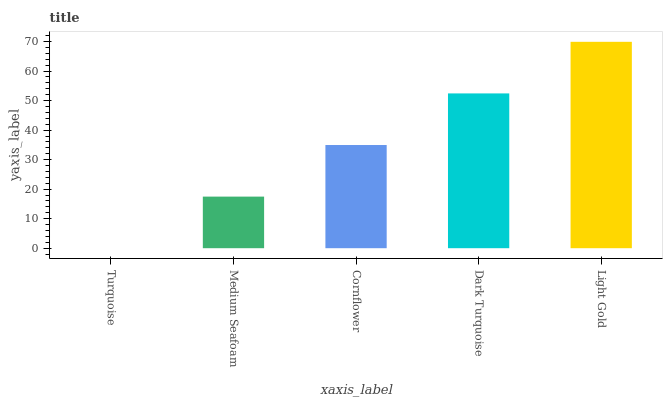Is Turquoise the minimum?
Answer yes or no. Yes. Is Light Gold the maximum?
Answer yes or no. Yes. Is Medium Seafoam the minimum?
Answer yes or no. No. Is Medium Seafoam the maximum?
Answer yes or no. No. Is Medium Seafoam greater than Turquoise?
Answer yes or no. Yes. Is Turquoise less than Medium Seafoam?
Answer yes or no. Yes. Is Turquoise greater than Medium Seafoam?
Answer yes or no. No. Is Medium Seafoam less than Turquoise?
Answer yes or no. No. Is Cornflower the high median?
Answer yes or no. Yes. Is Cornflower the low median?
Answer yes or no. Yes. Is Medium Seafoam the high median?
Answer yes or no. No. Is Medium Seafoam the low median?
Answer yes or no. No. 